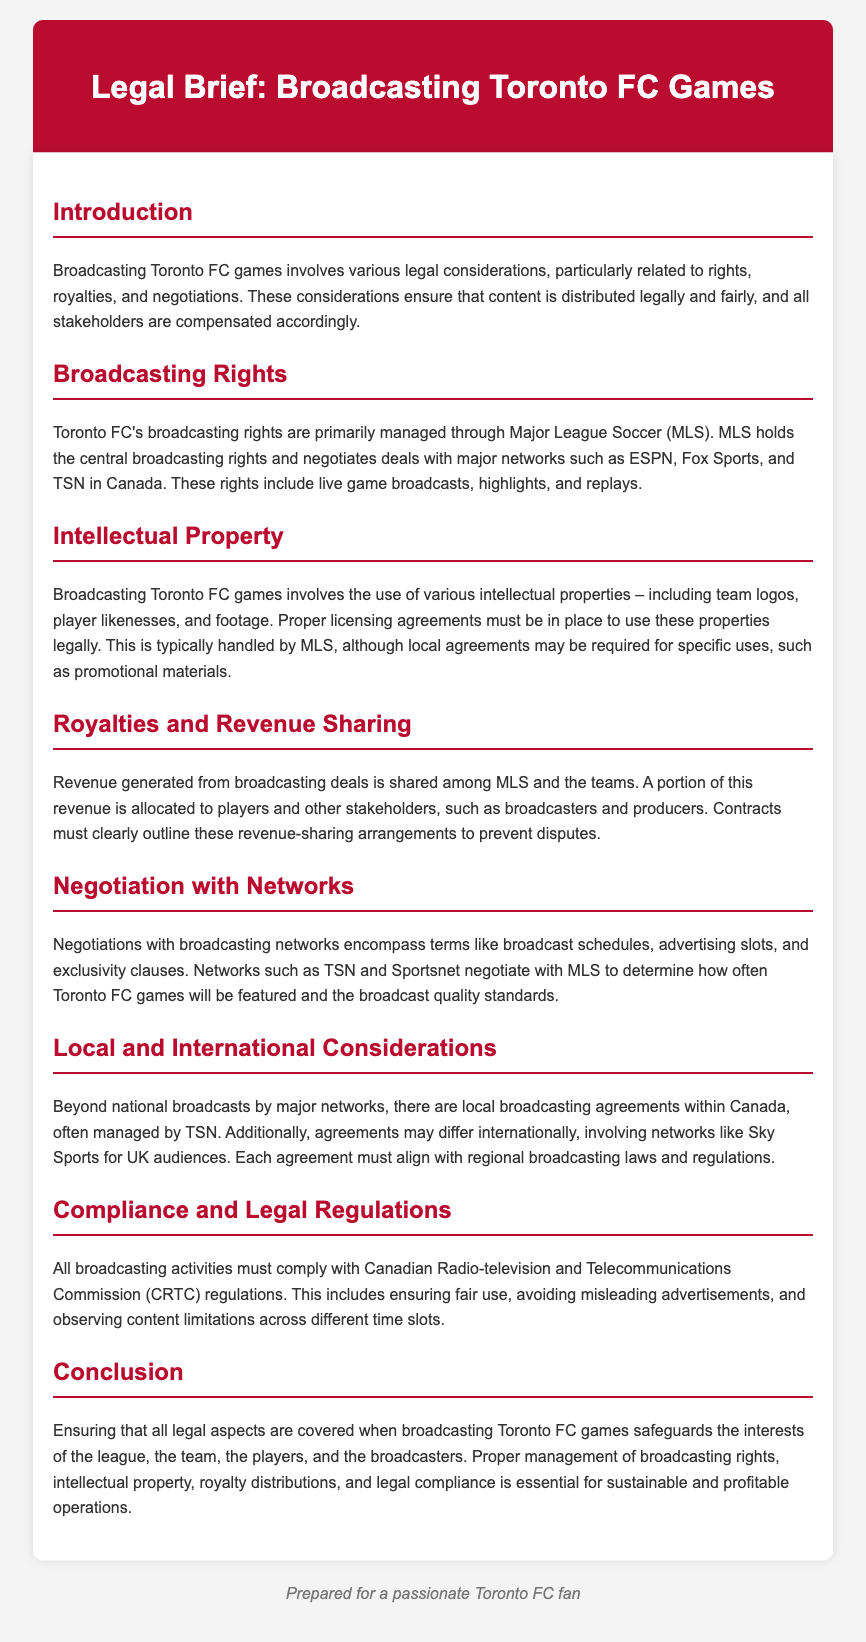what organization manages Toronto FC's broadcasting rights? The document states that MLS holds the central broadcasting rights for Toronto FC's games.
Answer: MLS which networks are mentioned as partners for broadcasting? The document lists ESPN, Fox Sports, and TSN as major networks involved in broadcasting.
Answer: ESPN, Fox Sports, TSN what must be in place to use team logos and player likenesses legally? The document mentions that proper licensing agreements must be established for using intellectual properties.
Answer: Licensing agreements who is responsible for negotiating broadcasting schedules and advertising slots? According to the document, networks such as TSN and Sportsnet negotiate these terms with MLS.
Answer: TSN and Sportsnet what governmental body regulates broadcasting activities in Canada? The document specifies that the Canadian Radio-television and Telecommunications Commission oversees broadcasting regulations.
Answer: CRTC how is revenue from broadcasting deals shared? The document states that revenue generated is shared among MLS and the teams, which is outlined in contracts.
Answer: Shared amongMLS and teams what do local broadcasting agreements in Canada often involve? The document indicates that local broadcasting agreements are often managed by TSN.
Answer: TSN which aspect of broadcasting must comply with specific laws and regulations? The document notes that all broadcasting activities must comply with CRTC regulations.
Answer: Broadcasting activities 